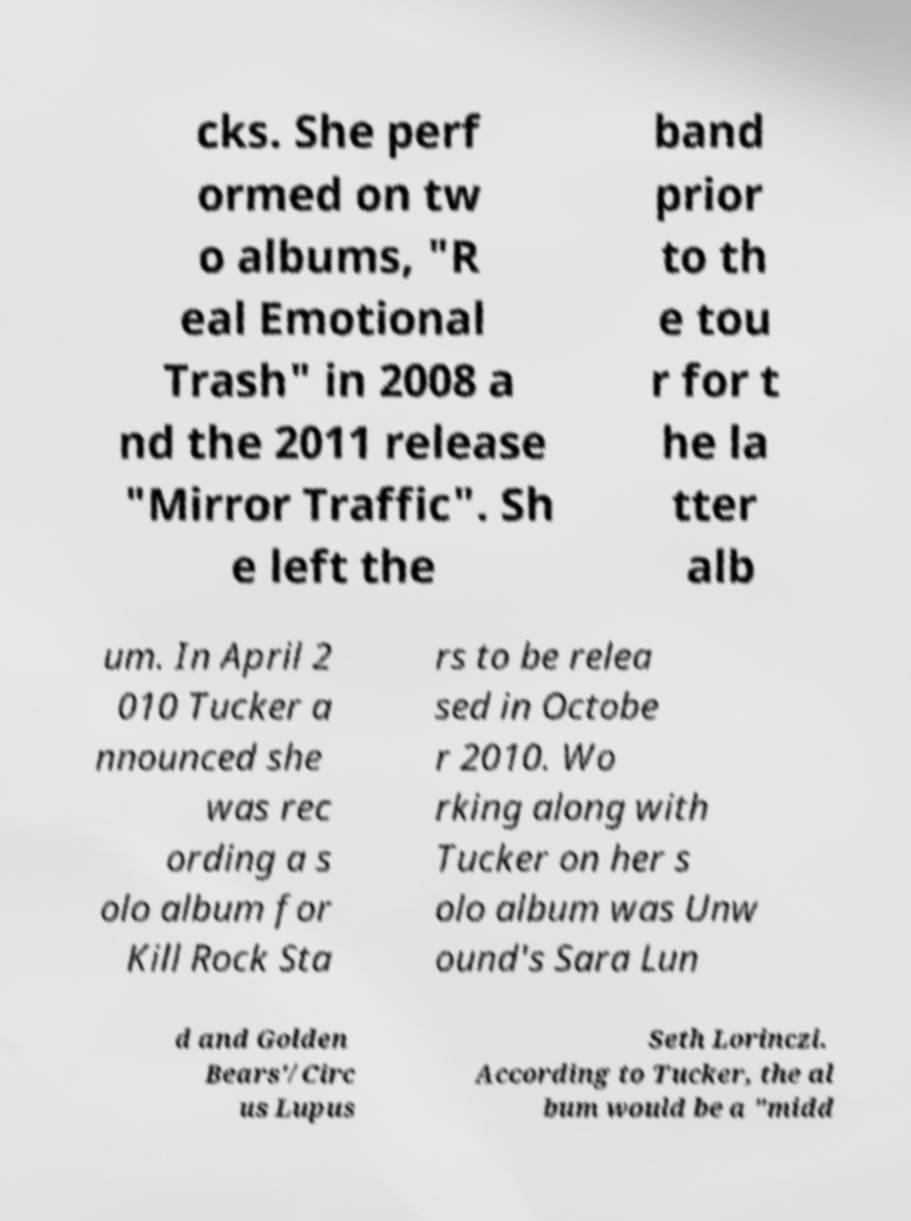I need the written content from this picture converted into text. Can you do that? cks. She perf ormed on tw o albums, "R eal Emotional Trash" in 2008 a nd the 2011 release "Mirror Traffic". Sh e left the band prior to th e tou r for t he la tter alb um. In April 2 010 Tucker a nnounced she was rec ording a s olo album for Kill Rock Sta rs to be relea sed in Octobe r 2010. Wo rking along with Tucker on her s olo album was Unw ound's Sara Lun d and Golden Bears'/Circ us Lupus Seth Lorinczi. According to Tucker, the al bum would be a "midd 